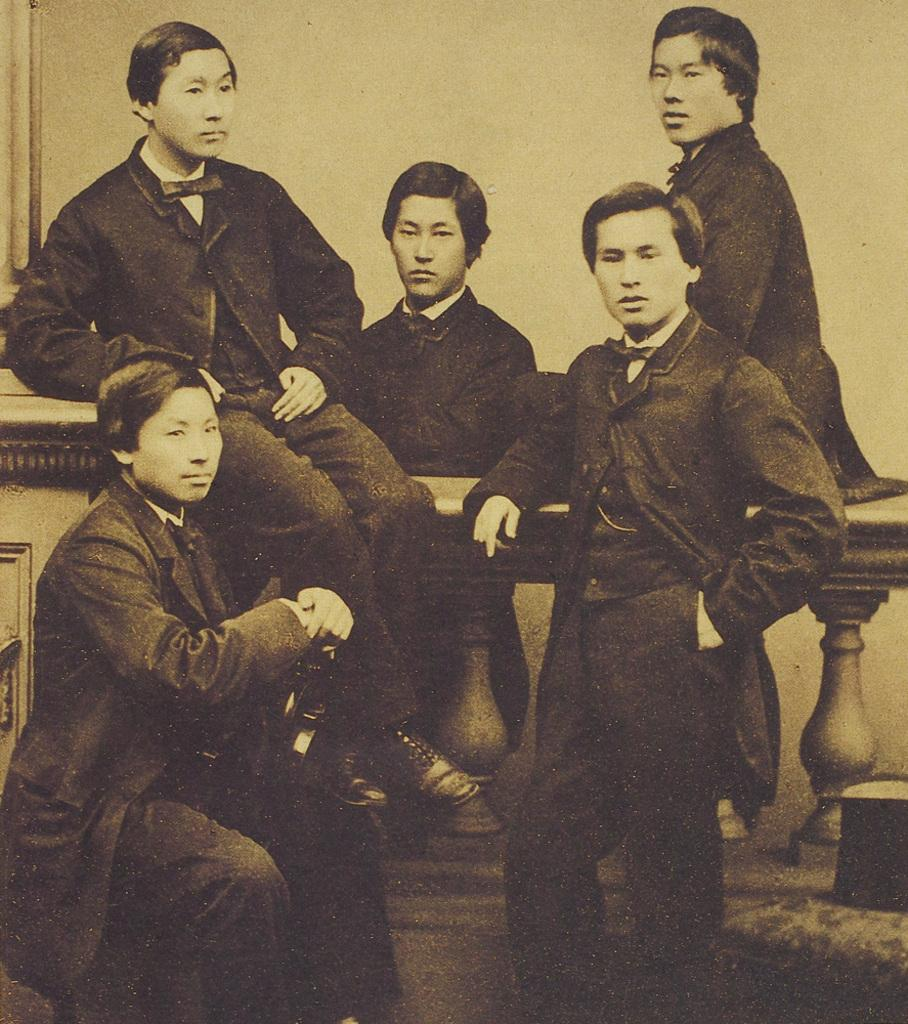Who or what can be seen in the image? There are people in the image. What is visible in the background of the image? There is a wall in the background of the image. Is there any glue visible on the wall in the image? There is no mention of glue in the image, so it cannot be determined if any is present. 